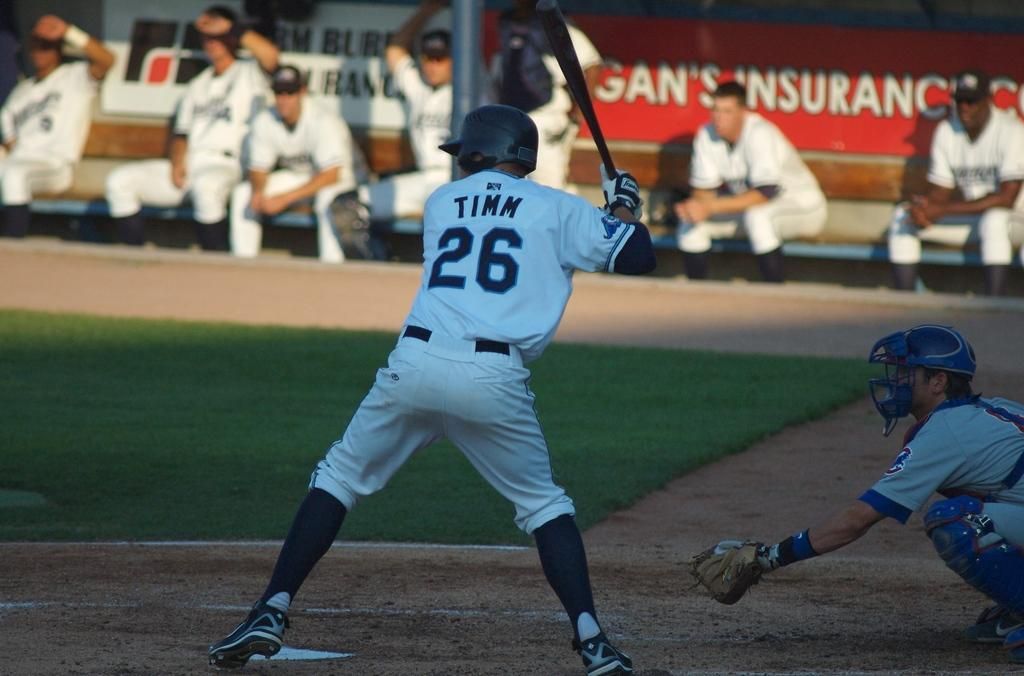<image>
Render a clear and concise summary of the photo. a baseball player in a Timm 26 jersey is up to bat 